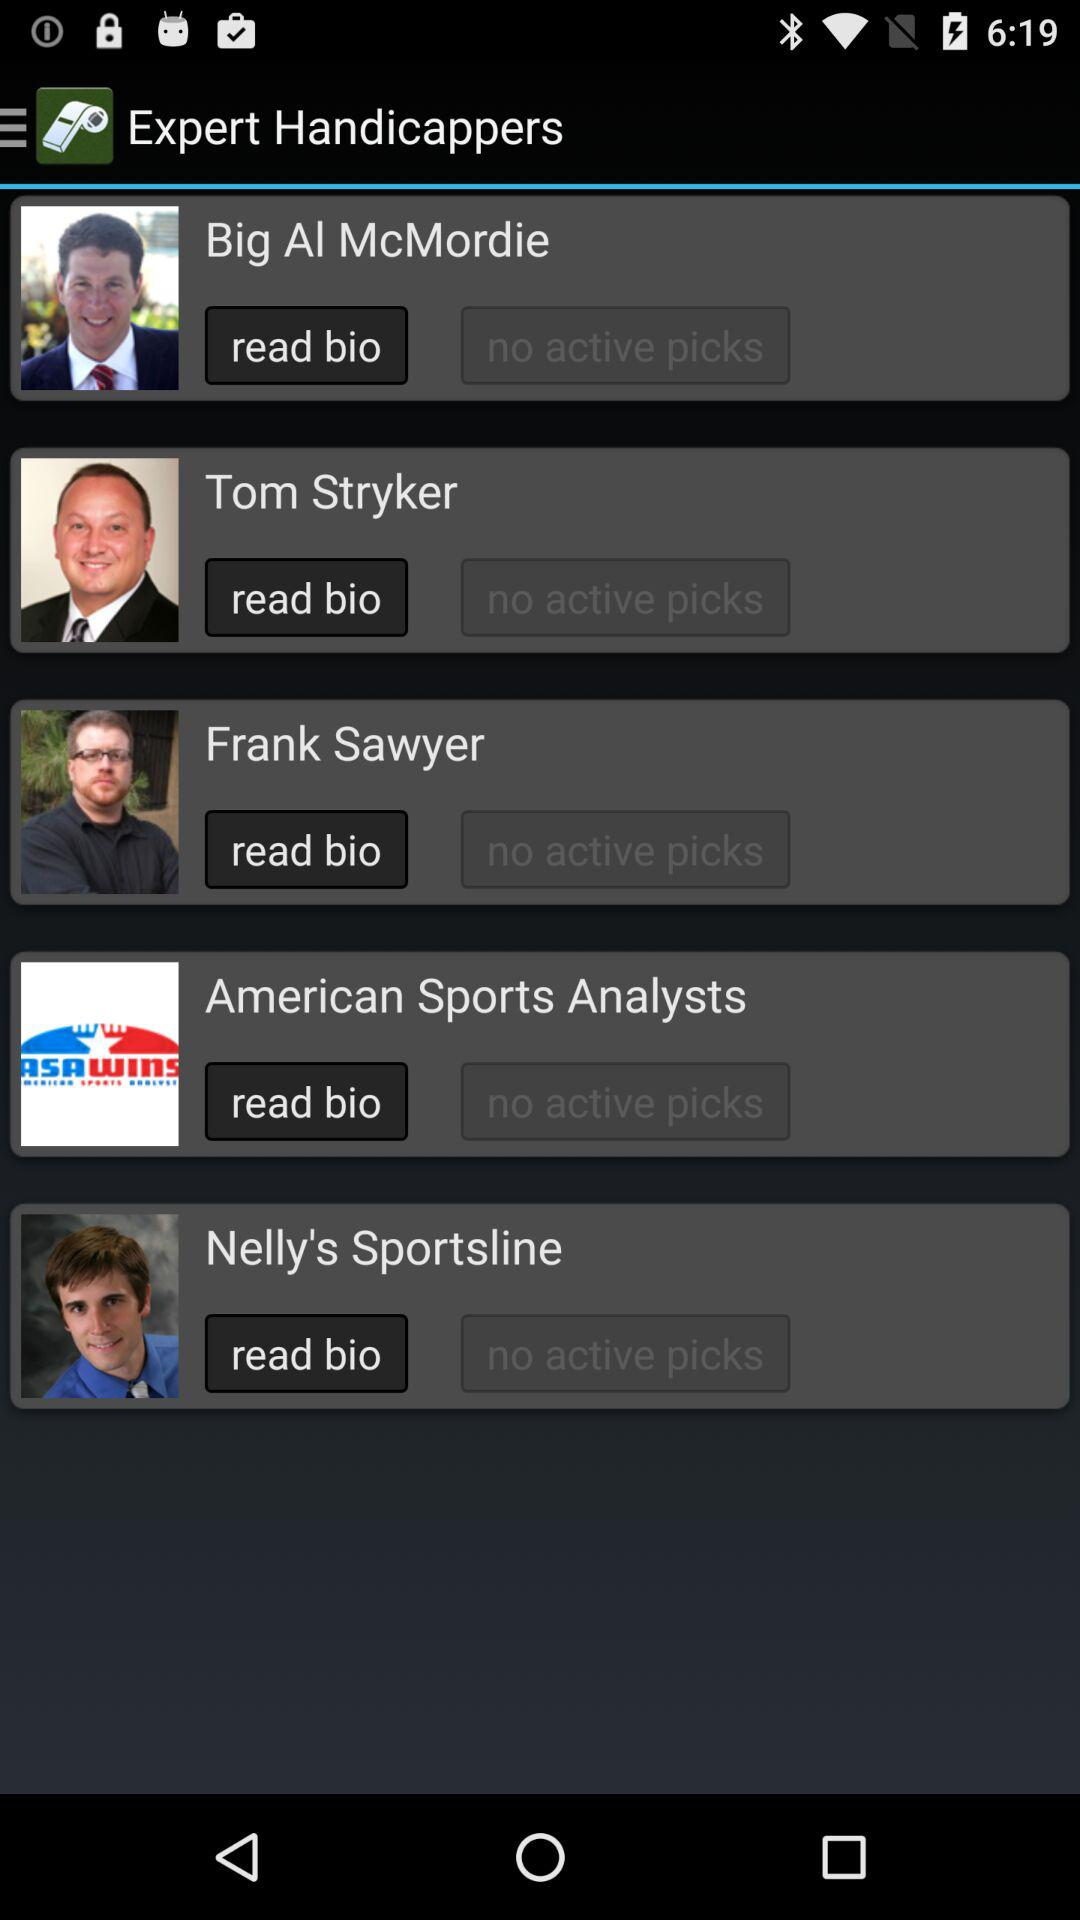Which details are given in Tom Stryker's bio?
When the provided information is insufficient, respond with <no answer>. <no answer> 